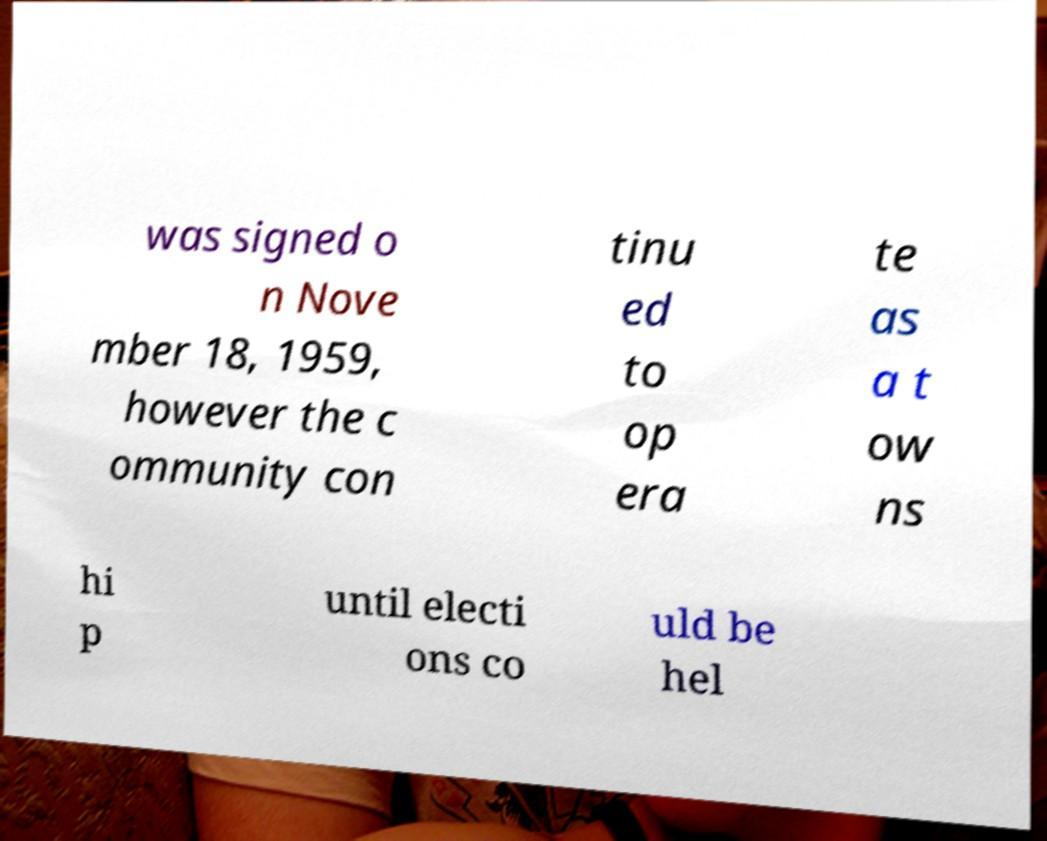There's text embedded in this image that I need extracted. Can you transcribe it verbatim? was signed o n Nove mber 18, 1959, however the c ommunity con tinu ed to op era te as a t ow ns hi p until electi ons co uld be hel 